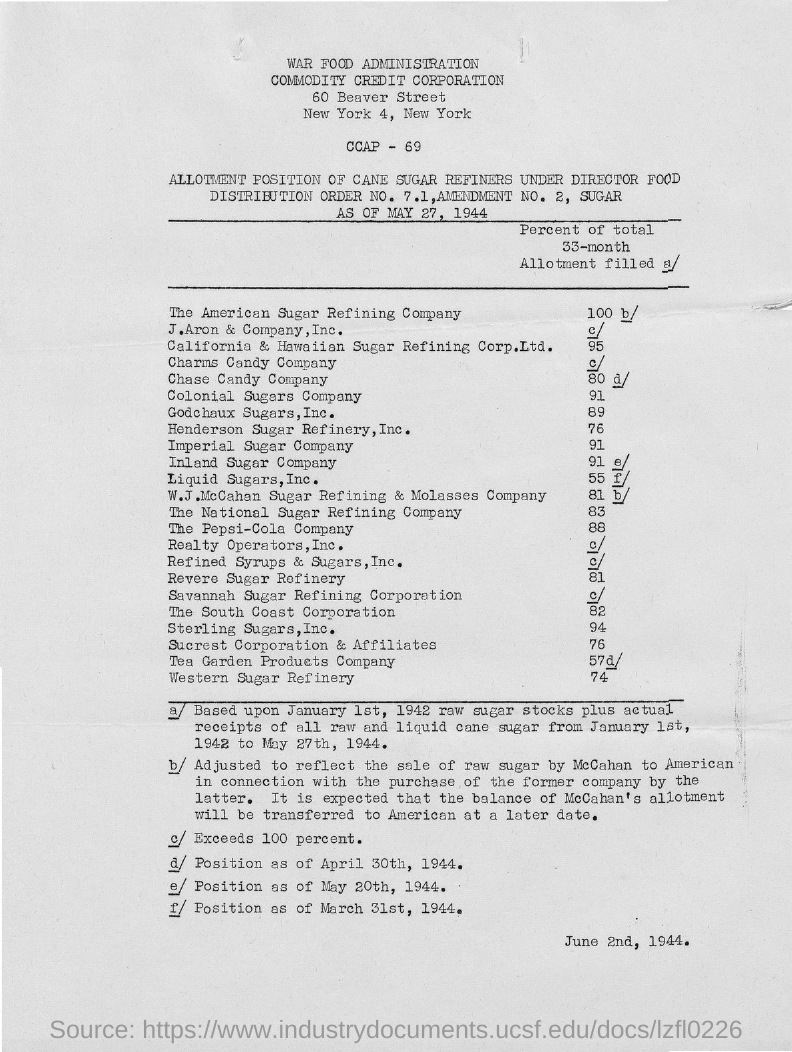What is the "DIRECTOR FOOD DISTRIBUTION ORDER NO."?
Ensure brevity in your answer.  7.1. What is the DIRECTOR FOOD DISTRIBUTION "AMENDMENT NO."?
Your response must be concise. 2. ALLOTMENT POSITION OF CANE SUGAR REFINERS as of which date is shown in the table?
Your response must be concise. MAY 27, 1944. Which city's name is seen in the letterhead?
Your answer should be very brief. New York. What is the Percent of total for "Colonial Sugars Company"?
Offer a very short reply. 91. What is the Percent of total for "Henderson Sugar Refinery,Inc."?
Make the answer very short. 76. What is the Percent of total for "Pepsi-Cola Company"?
Your response must be concise. 88. What is the Percent of total for "National Sugar Refining Company"?
Make the answer very short. 83. What is the Percent of total for "Western Sugar Refinery"?
Offer a terse response. 74. What is the date mentioned at the right bottom of the document?
Your answer should be compact. June 2nd, 1944. 